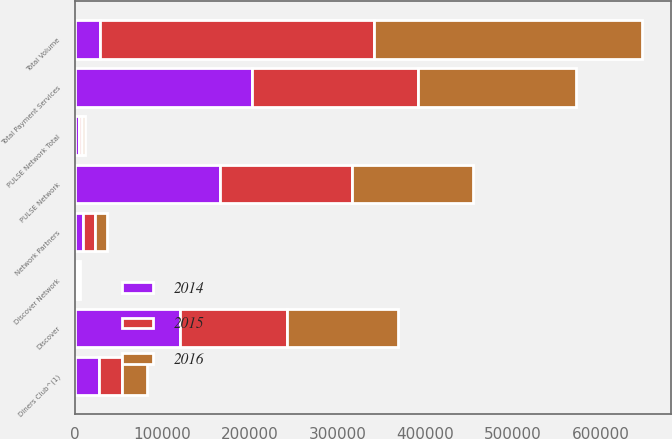Convert chart. <chart><loc_0><loc_0><loc_500><loc_500><stacked_bar_chart><ecel><fcel>PULSE Network<fcel>Network Partners<fcel>Diners Club^(1)<fcel>Total Payment Services<fcel>Discover<fcel>Total Volume<fcel>Discover Network<fcel>PULSE Network Total<nl><fcel>2016<fcel>138003<fcel>13833<fcel>28601<fcel>180437<fcel>126144<fcel>306581<fcel>2125<fcel>3456<nl><fcel>2015<fcel>150145<fcel>12965<fcel>26567<fcel>189677<fcel>122726<fcel>312403<fcel>2033<fcel>3890<nl><fcel>2014<fcel>165851<fcel>9446<fcel>26970<fcel>202267<fcel>119471<fcel>28601<fcel>2020<fcel>4283<nl></chart> 